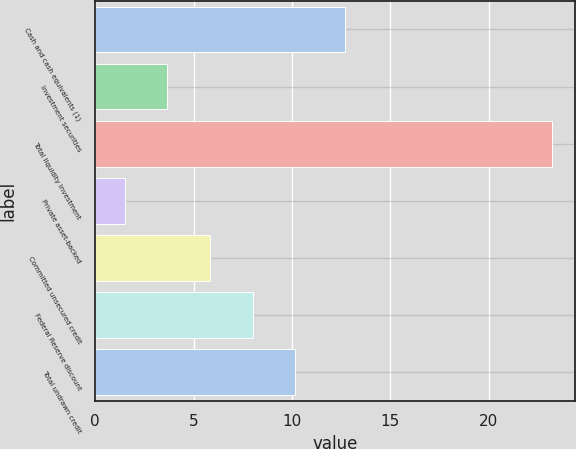<chart> <loc_0><loc_0><loc_500><loc_500><bar_chart><fcel>Cash and cash equivalents (1)<fcel>Investment securities<fcel>Total liquidity investment<fcel>Private asset-backed<fcel>Committed unsecured credit<fcel>Federal Reserve discount<fcel>Total undrawn credit<nl><fcel>12.7<fcel>3.67<fcel>23.2<fcel>1.5<fcel>5.84<fcel>8.01<fcel>10.18<nl></chart> 